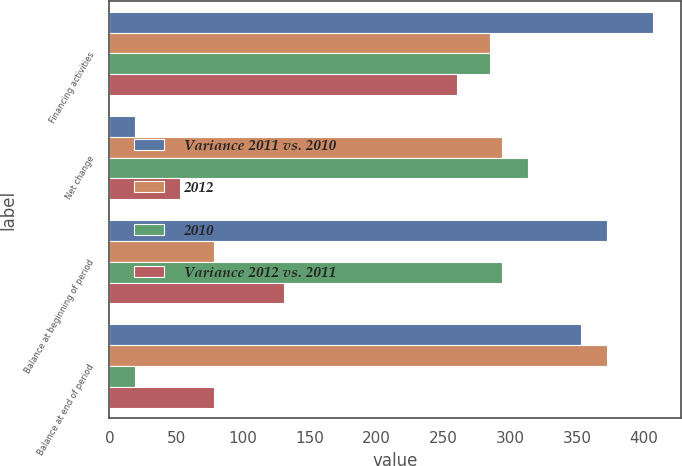Convert chart to OTSL. <chart><loc_0><loc_0><loc_500><loc_500><stacked_bar_chart><ecel><fcel>Financing activities<fcel>Net change<fcel>Balance at beginning of period<fcel>Balance at end of period<nl><fcel>Variance 2011 vs. 2010<fcel>407<fcel>19<fcel>372<fcel>353<nl><fcel>2012<fcel>285<fcel>294<fcel>78<fcel>372<nl><fcel>2010<fcel>285<fcel>313<fcel>294<fcel>19<nl><fcel>Variance 2012 vs. 2011<fcel>260<fcel>53<fcel>131<fcel>78<nl></chart> 